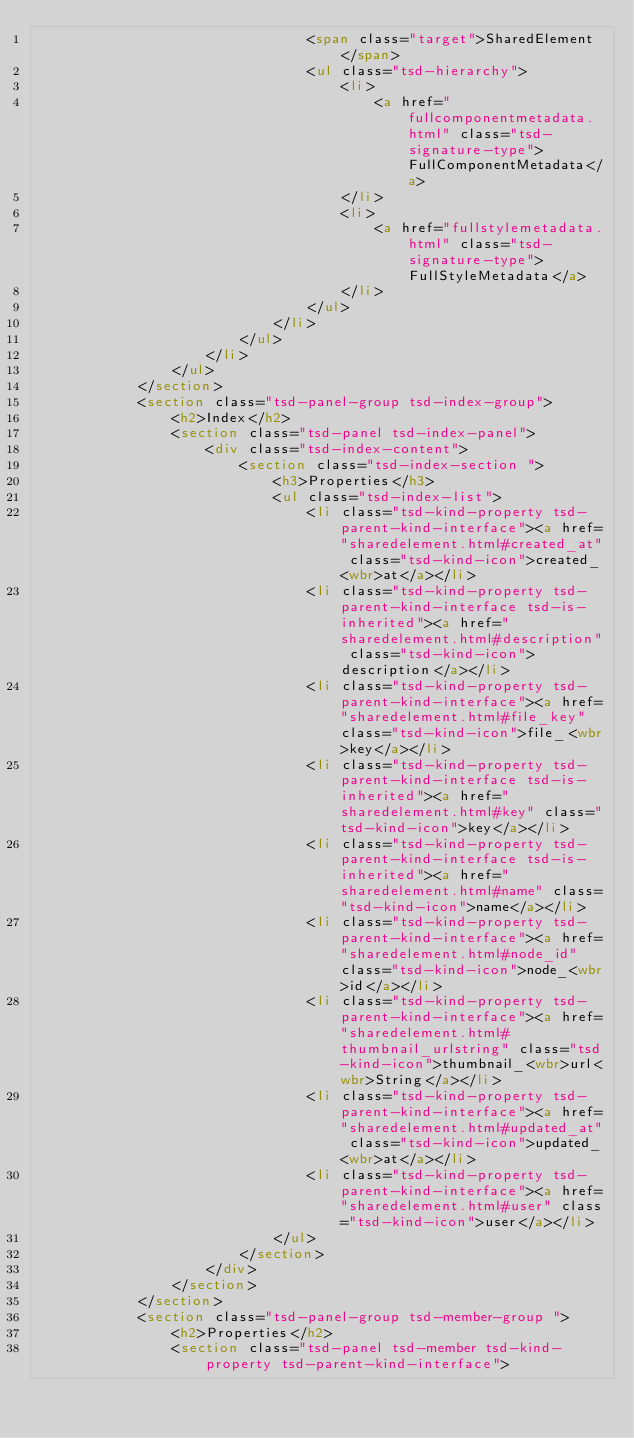Convert code to text. <code><loc_0><loc_0><loc_500><loc_500><_HTML_>								<span class="target">SharedElement</span>
								<ul class="tsd-hierarchy">
									<li>
										<a href="fullcomponentmetadata.html" class="tsd-signature-type">FullComponentMetadata</a>
									</li>
									<li>
										<a href="fullstylemetadata.html" class="tsd-signature-type">FullStyleMetadata</a>
									</li>
								</ul>
							</li>
						</ul>
					</li>
				</ul>
			</section>
			<section class="tsd-panel-group tsd-index-group">
				<h2>Index</h2>
				<section class="tsd-panel tsd-index-panel">
					<div class="tsd-index-content">
						<section class="tsd-index-section ">
							<h3>Properties</h3>
							<ul class="tsd-index-list">
								<li class="tsd-kind-property tsd-parent-kind-interface"><a href="sharedelement.html#created_at" class="tsd-kind-icon">created_<wbr>at</a></li>
								<li class="tsd-kind-property tsd-parent-kind-interface tsd-is-inherited"><a href="sharedelement.html#description" class="tsd-kind-icon">description</a></li>
								<li class="tsd-kind-property tsd-parent-kind-interface"><a href="sharedelement.html#file_key" class="tsd-kind-icon">file_<wbr>key</a></li>
								<li class="tsd-kind-property tsd-parent-kind-interface tsd-is-inherited"><a href="sharedelement.html#key" class="tsd-kind-icon">key</a></li>
								<li class="tsd-kind-property tsd-parent-kind-interface tsd-is-inherited"><a href="sharedelement.html#name" class="tsd-kind-icon">name</a></li>
								<li class="tsd-kind-property tsd-parent-kind-interface"><a href="sharedelement.html#node_id" class="tsd-kind-icon">node_<wbr>id</a></li>
								<li class="tsd-kind-property tsd-parent-kind-interface"><a href="sharedelement.html#thumbnail_urlstring" class="tsd-kind-icon">thumbnail_<wbr>url<wbr>String</a></li>
								<li class="tsd-kind-property tsd-parent-kind-interface"><a href="sharedelement.html#updated_at" class="tsd-kind-icon">updated_<wbr>at</a></li>
								<li class="tsd-kind-property tsd-parent-kind-interface"><a href="sharedelement.html#user" class="tsd-kind-icon">user</a></li>
							</ul>
						</section>
					</div>
				</section>
			</section>
			<section class="tsd-panel-group tsd-member-group ">
				<h2>Properties</h2>
				<section class="tsd-panel tsd-member tsd-kind-property tsd-parent-kind-interface"></code> 